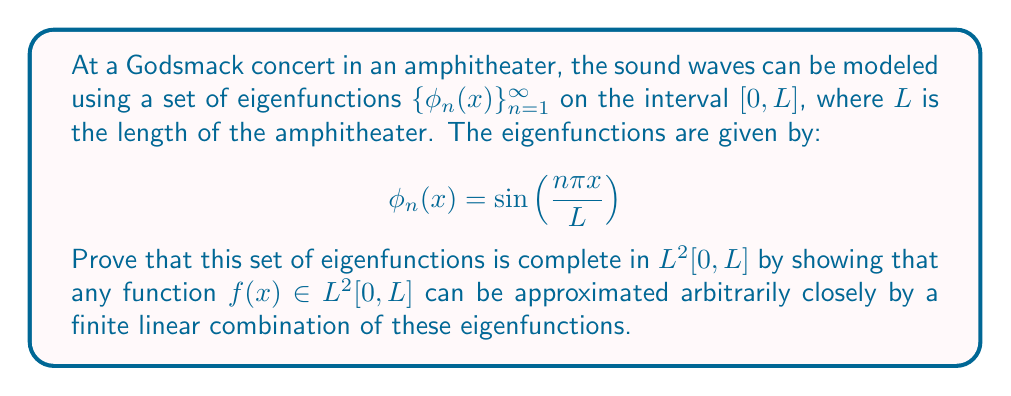Give your solution to this math problem. To prove the completeness of the set of eigenfunctions $\{\phi_n(x)\}_{n=1}^{\infty}$, we need to show that they form an orthonormal basis for $L^2[0,L]$. We'll do this in steps:

1) First, let's verify that the eigenfunctions are orthonormal:

   $$\int_0^L \phi_m(x)\phi_n(x)dx = \int_0^L \sin\left(\frac{m\pi x}{L}\right)\sin\left(\frac{n\pi x}{L}\right)dx = \frac{L}{2}\delta_{mn}$$

   where $\delta_{mn}$ is the Kronecker delta. This shows the functions are orthogonal and can be normalized by multiplying by $\sqrt{\frac{2}{L}}$.

2) Now, let's consider an arbitrary function $f(x) \in L^2[0,L]$. We can express this function as a Fourier series:

   $$f(x) = \sum_{n=1}^{\infty} c_n \sin\left(\frac{n\pi x}{L}\right)$$

   where the coefficients $c_n$ are given by:

   $$c_n = \frac{2}{L}\int_0^L f(x)\sin\left(\frac{n\pi x}{L}\right)dx$$

3) To prove completeness, we need to show that the partial sums of this series converge to $f(x)$ in the $L^2$ norm. Let's define the partial sum:

   $$S_N(x) = \sum_{n=1}^N c_n \sin\left(\frac{n\pi x}{L}\right)$$

4) We want to show that:

   $$\lim_{N\to\infty} \|f - S_N\|_{L^2} = 0$$

5) Using Parseval's identity, we can write:

   $$\|f\|_{L^2}^2 = \sum_{n=1}^{\infty} |c_n|^2$$

6) The error in approximation can be written as:

   $$\|f - S_N\|_{L^2}^2 = \sum_{n=N+1}^{\infty} |c_n|^2$$

7) As $N \to \infty$, this error approaches zero because the series $\sum_{n=1}^{\infty} |c_n|^2$ converges (it equals $\|f\|_{L^2}^2$, which is finite for $f \in L^2[0,L]$).

Therefore, we have shown that any function in $L^2[0,L]$ can be approximated arbitrarily closely by a finite linear combination of the eigenfunctions $\{\phi_n(x)\}_{n=1}^{\infty}$, proving their completeness.
Answer: The set of eigenfunctions $\{\phi_n(x) = \sin(\frac{n\pi x}{L})\}_{n=1}^{\infty}$ is complete in $L^2[0,L]$. 